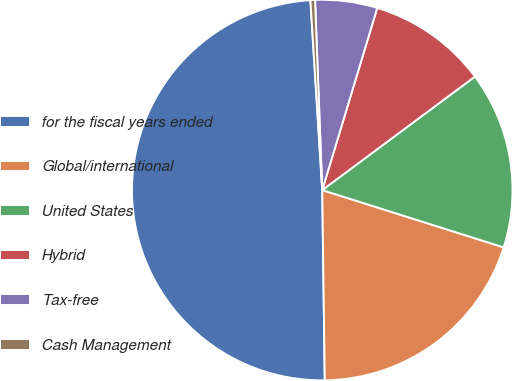<chart> <loc_0><loc_0><loc_500><loc_500><pie_chart><fcel>for the fiscal years ended<fcel>Global/international<fcel>United States<fcel>Hybrid<fcel>Tax-free<fcel>Cash Management<nl><fcel>49.22%<fcel>19.92%<fcel>15.04%<fcel>10.16%<fcel>5.27%<fcel>0.39%<nl></chart> 